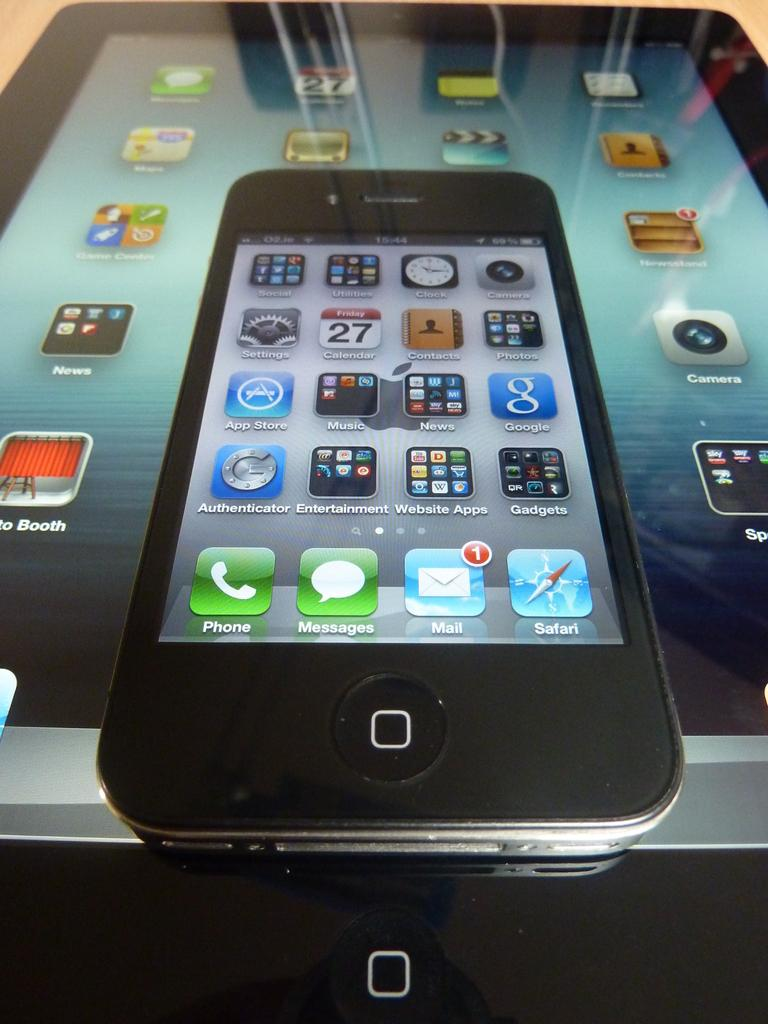<image>
Describe the image concisely. A cell phone shows apps and phone and messages icon. 